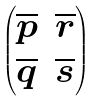Convert formula to latex. <formula><loc_0><loc_0><loc_500><loc_500>\begin{pmatrix} \overline { p } & \overline { r } \\ \overline { q } & \overline { s } \end{pmatrix}</formula> 